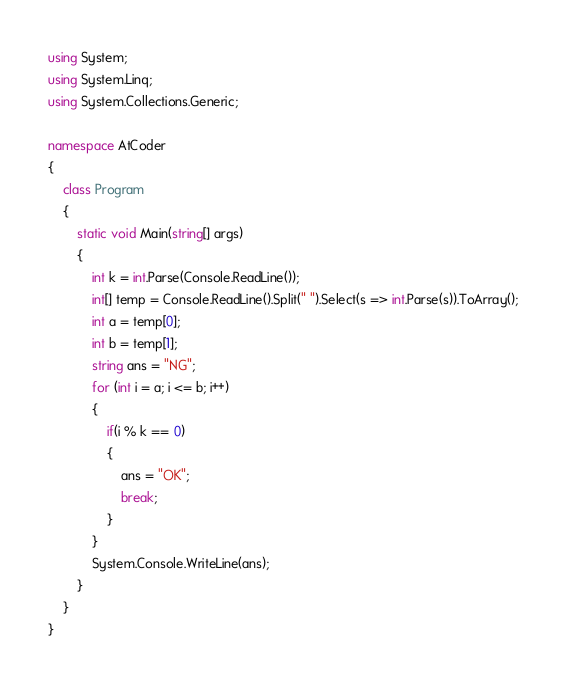Convert code to text. <code><loc_0><loc_0><loc_500><loc_500><_C#_>using System;
using System.Linq;
using System.Collections.Generic;

namespace AtCoder
{
    class Program
    {
        static void Main(string[] args)
        {
            int k = int.Parse(Console.ReadLine());
            int[] temp = Console.ReadLine().Split(" ").Select(s => int.Parse(s)).ToArray();
            int a = temp[0];
            int b = temp[1];
            string ans = "NG";
            for (int i = a; i <= b; i++)
            {
                if(i % k == 0)
                {
                    ans = "OK";
                    break;
                }
            }
            System.Console.WriteLine(ans);
        }
    }
}</code> 